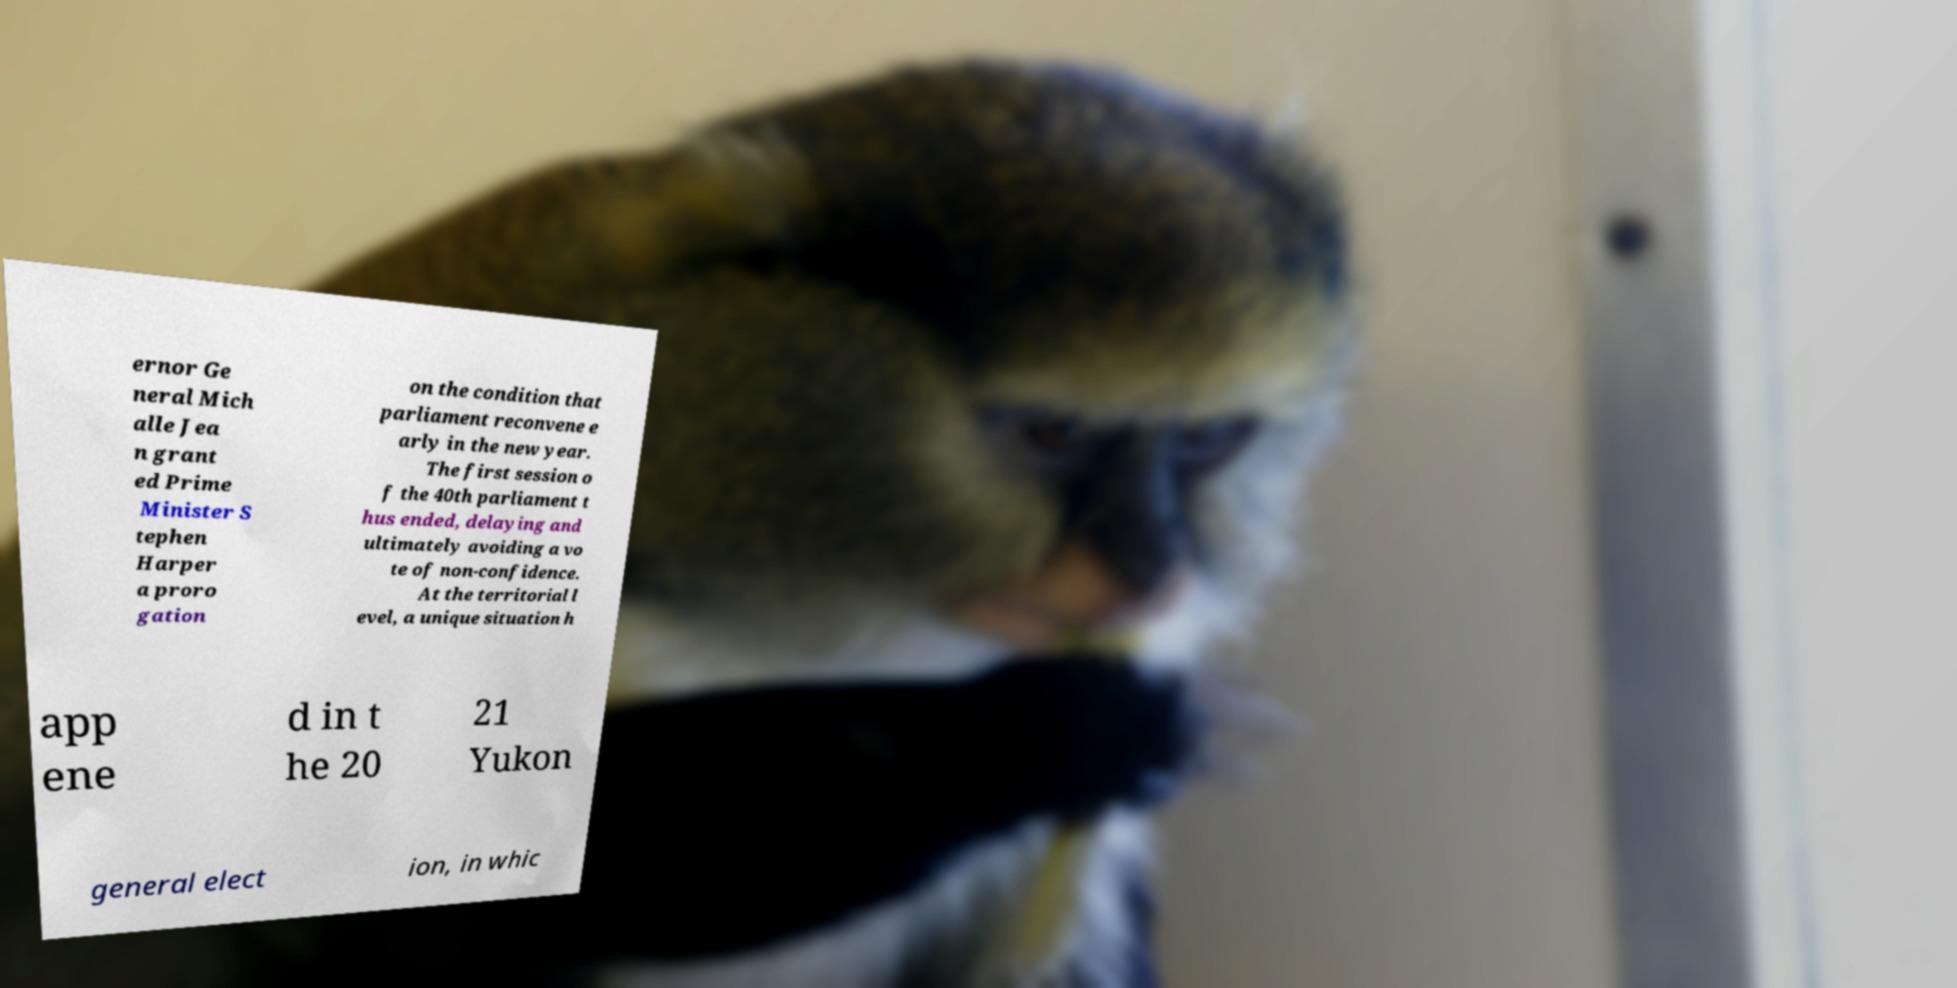I need the written content from this picture converted into text. Can you do that? ernor Ge neral Mich alle Jea n grant ed Prime Minister S tephen Harper a proro gation on the condition that parliament reconvene e arly in the new year. The first session o f the 40th parliament t hus ended, delaying and ultimately avoiding a vo te of non-confidence. At the territorial l evel, a unique situation h app ene d in t he 20 21 Yukon general elect ion, in whic 